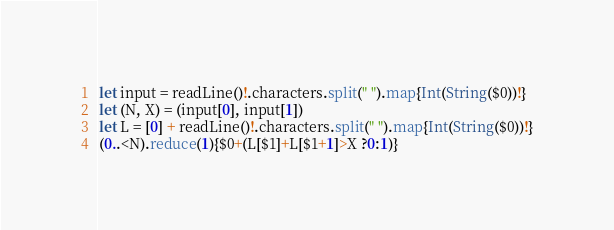Convert code to text. <code><loc_0><loc_0><loc_500><loc_500><_Swift_>let input = readLine()!.characters.split(" ").map{Int(String($0))!}
let (N, X) = (input[0], input[1])
let L = [0] + readLine()!.characters.split(" ").map{Int(String($0))!}
(0..<N).reduce(1){$0+(L[$1]+L[$1+1]>X ?0:1)}</code> 